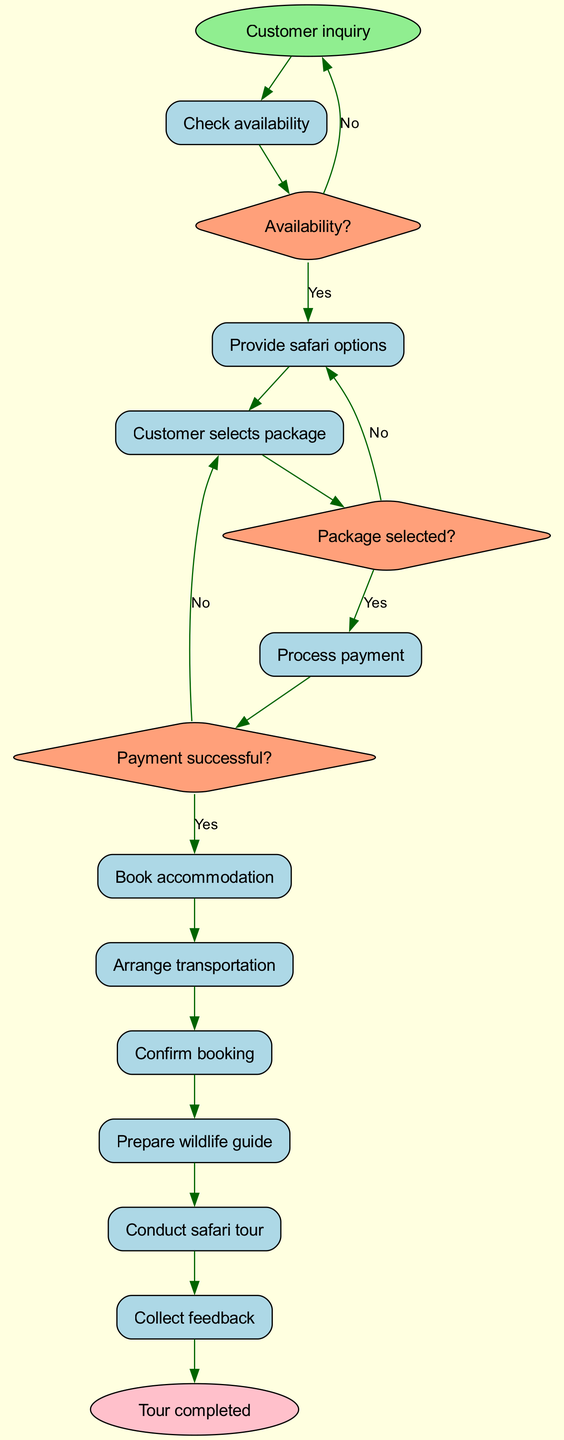What is the first activity in the diagram? The first activity is directly connected to the start node. The diagram indicates that after the customer inquiry, the first task is to check availability.
Answer: Check availability How many activities are there in total? To find the total activities, we count each activity listed in the activities section of the diagram. There are ten listed activities in total.
Answer: 10 What happens if the availability check is negative? If the availability check indicates "No," the diagram shows that the process returns to the start node, meaning the customer inquiry will be initiated again.
Answer: Return to start What is the last step before the tour is completed? The last activity mentioned before reaching the end node is collecting feedback. This activity directly precedes the 'Tour completed' end node.
Answer: Collect feedback Which decision involves payment processing? The decision that involves payment processing is the one labeled "Payment successful?" This comes after the activity where payment is processed.
Answer: Payment successful? What do we do if the package selection is negative? If the customer did not select a package, the diagram indicates that the flow returns to the "Provide safari options" activity. This means there will be an attempt to provide different package options.
Answer: Provide safari options How many decisions are made throughout the process? There are three decisions indicated in the diagram: "Availability?", "Package selected?", and "Payment successful?". We count each decision to arrive at the total.
Answer: 3 What is required before confirming the booking? Before confirming the booking, all prior processes, including checking availability, package selection, and processing payment, must be completed successfully. Therefore, the activities must be followed in order as specified in the diagram.
Answer: Successful completion of prior activities 